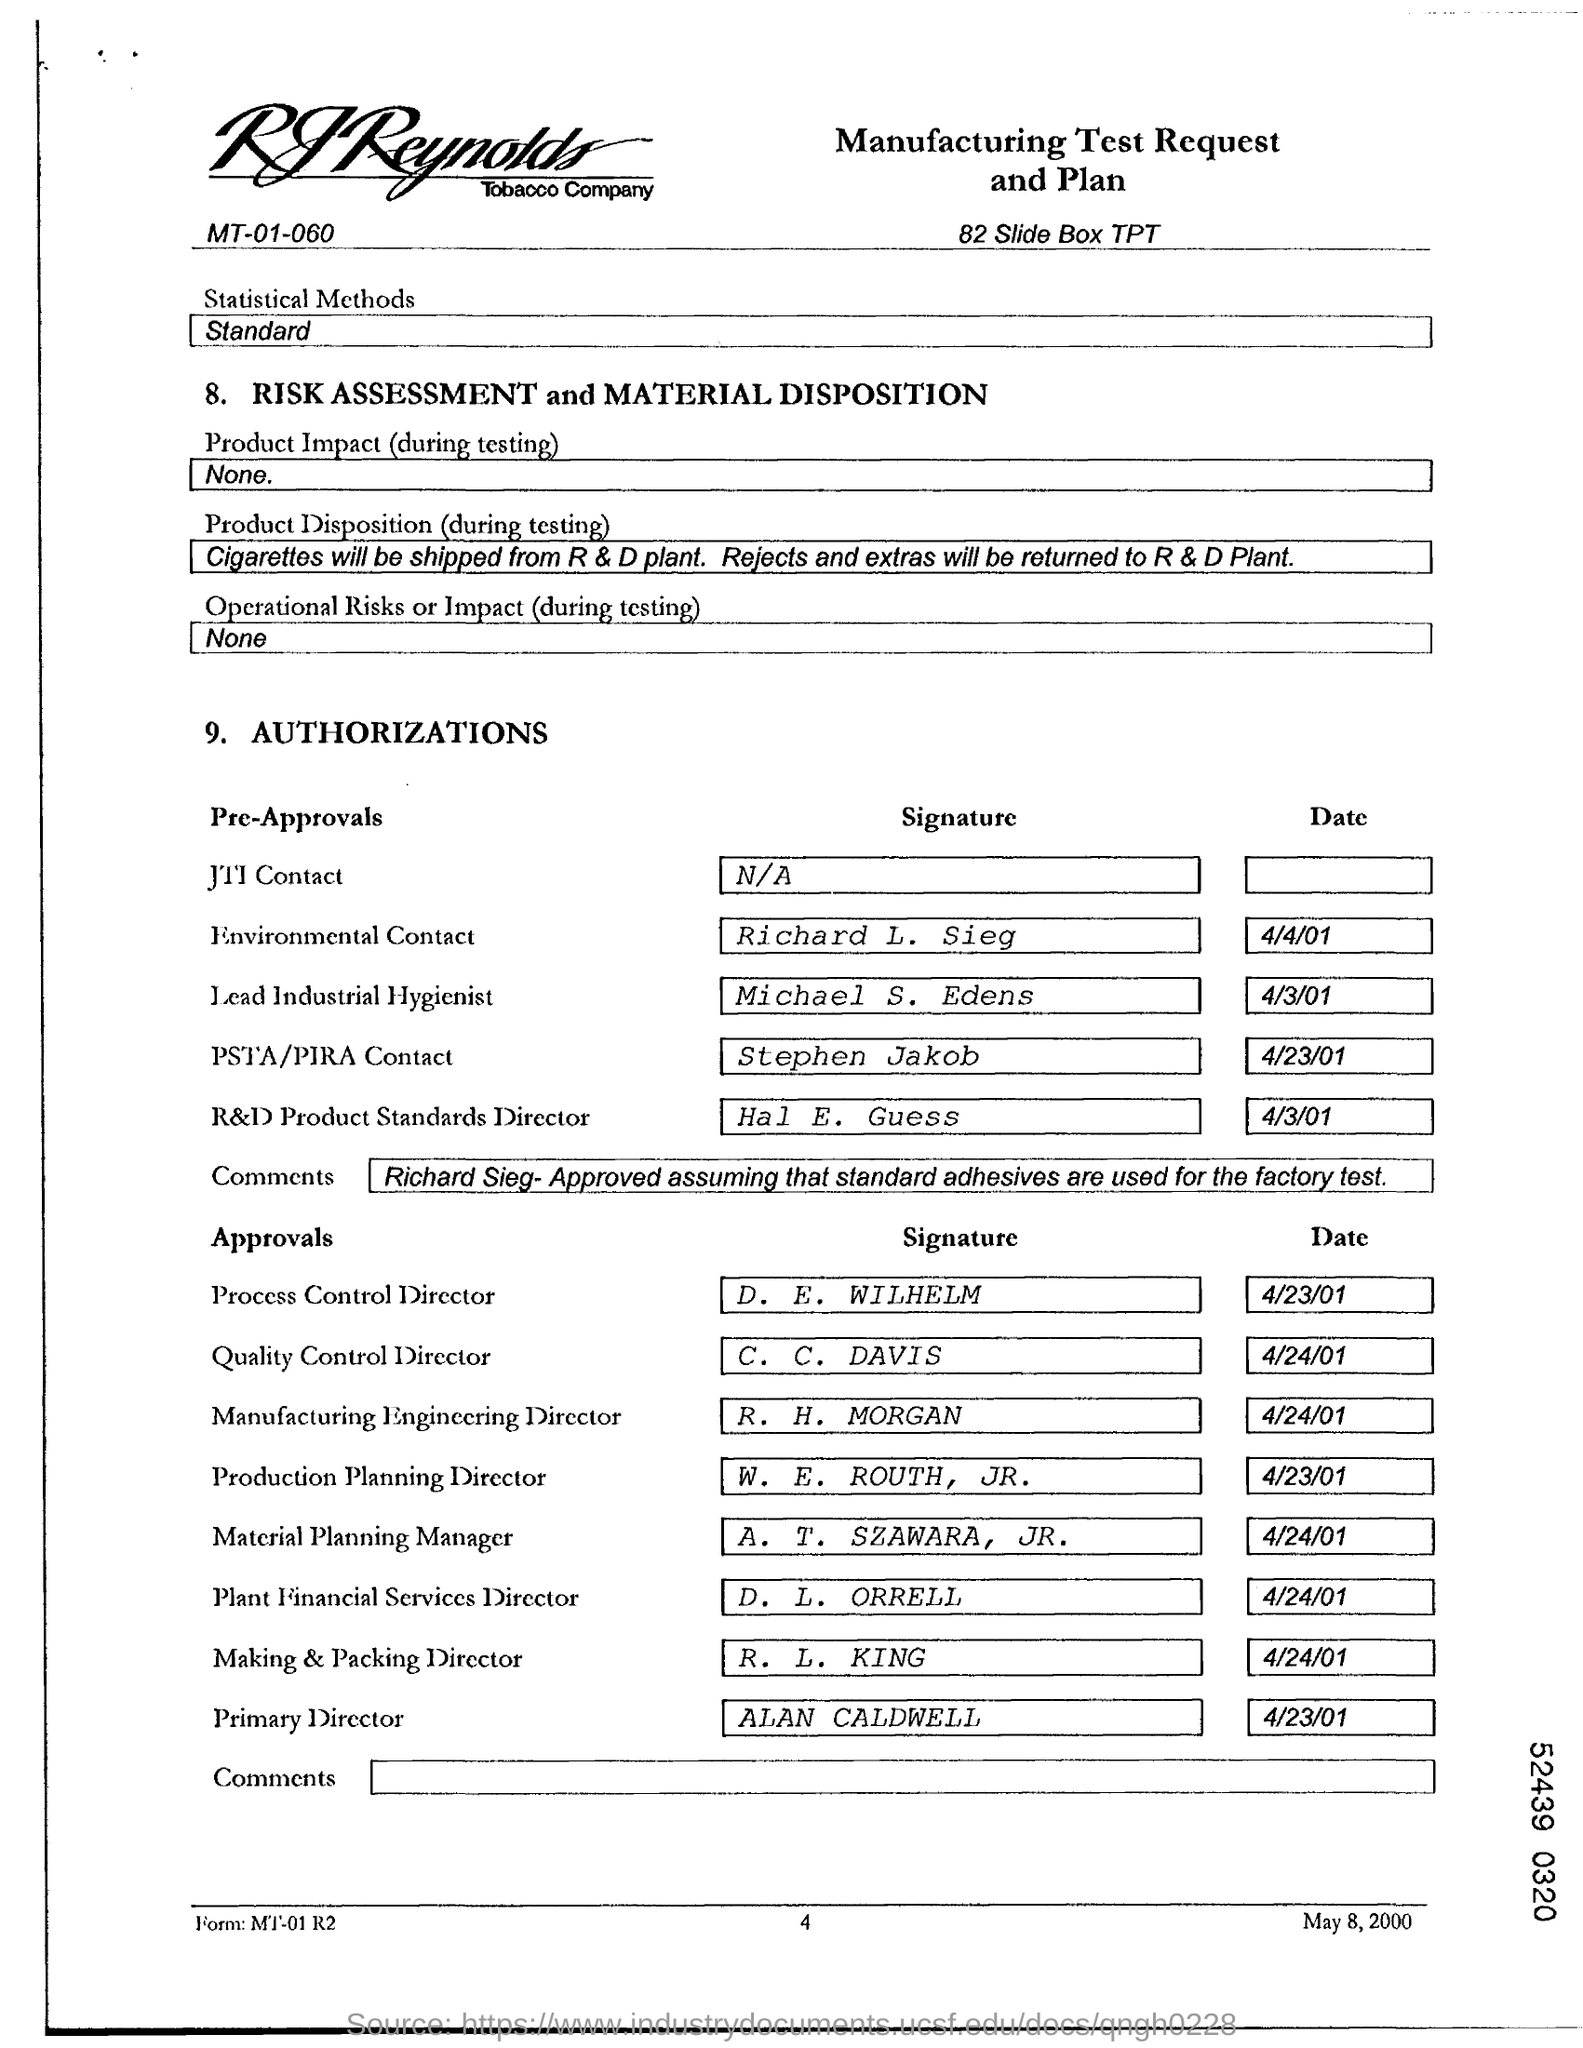Draw attention to some important aspects in this diagram. The date for Michael S. Edens is April 3, 2001. The individual designated as the Quality Control Director is C. C. Davis. The Process Control Director is D. E. Wilhelm. On April 23, 2001, the date for Alan Caldwell, is what is referred to as the 'Date'. 